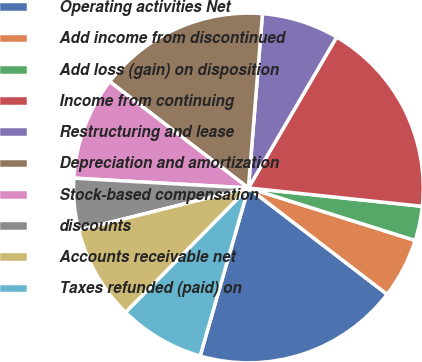Convert chart. <chart><loc_0><loc_0><loc_500><loc_500><pie_chart><fcel>Operating activities Net<fcel>Add income from discontinued<fcel>Add loss (gain) on disposition<fcel>Income from continuing<fcel>Restructuring and lease<fcel>Depreciation and amortization<fcel>Stock-based compensation<fcel>discounts<fcel>Accounts receivable net<fcel>Taxes refunded (paid) on<nl><fcel>19.04%<fcel>5.56%<fcel>3.18%<fcel>18.25%<fcel>7.14%<fcel>15.87%<fcel>9.52%<fcel>4.77%<fcel>8.73%<fcel>7.94%<nl></chart> 